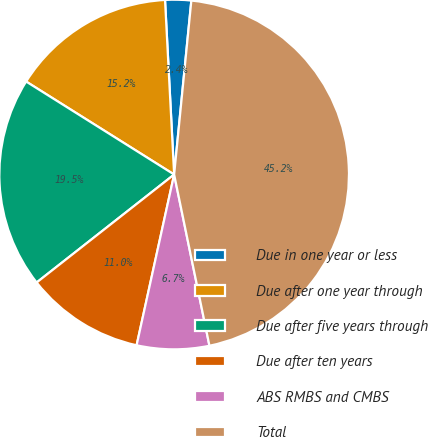Convert chart. <chart><loc_0><loc_0><loc_500><loc_500><pie_chart><fcel>Due in one year or less<fcel>Due after one year through<fcel>Due after five years through<fcel>Due after ten years<fcel>ABS RMBS and CMBS<fcel>Total<nl><fcel>2.4%<fcel>15.24%<fcel>19.52%<fcel>10.96%<fcel>6.68%<fcel>45.19%<nl></chart> 